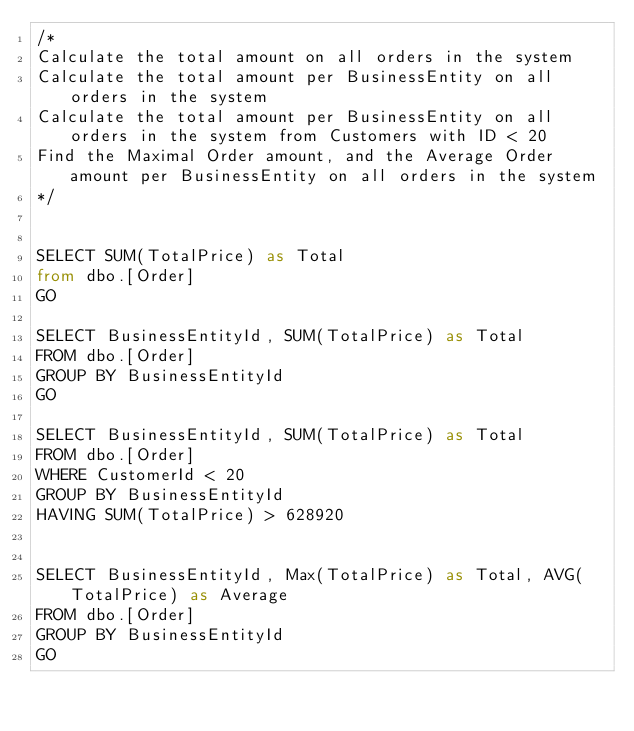Convert code to text. <code><loc_0><loc_0><loc_500><loc_500><_SQL_>/*
Calculate the total amount on all orders in the system
Calculate the total amount per BusinessEntity on all orders in the system
Calculate the total amount per BusinessEntity on all orders in the system from Customers with ID < 20
Find the Maximal Order amount, and the Average Order amount per BusinessEntity on all orders in the system
*/


SELECT SUM(TotalPrice) as Total
from dbo.[Order]
GO

SELECT BusinessEntityId, SUM(TotalPrice) as Total
FROM dbo.[Order]
GROUP BY BusinessEntityId
GO

SELECT BusinessEntityId, SUM(TotalPrice) as Total
FROM dbo.[Order]
WHERE CustomerId < 20
GROUP BY BusinessEntityId
HAVING SUM(TotalPrice) > 628920


SELECT BusinessEntityId, Max(TotalPrice) as Total, AVG(TotalPrice) as Average
FROM dbo.[Order]
GROUP BY BusinessEntityId
GO
</code> 